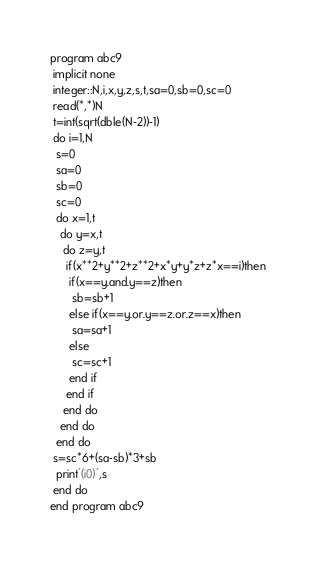<code> <loc_0><loc_0><loc_500><loc_500><_FORTRAN_>program abc9
 implicit none
 integer::N,i,x,y,z,s,t,sa=0,sb=0,sc=0
 read(*,*)N
 t=int(sqrt(dble(N-2))-1)
 do i=1,N
  s=0
  sa=0
  sb=0
  sc=0
  do x=1,t
   do y=x,t
    do z=y,t
     if(x**2+y**2+z**2+x*y+y*z+z*x==i)then
      if(x==y.and.y==z)then
       sb=sb+1
      else if(x==y.or.y==z.or.z==x)then
       sa=sa+1
      else
       sc=sc+1
      end if
     end if
    end do
   end do
  end do
 s=sc*6+(sa-sb)*3+sb
  print'(i0)',s
 end do
end program abc9</code> 